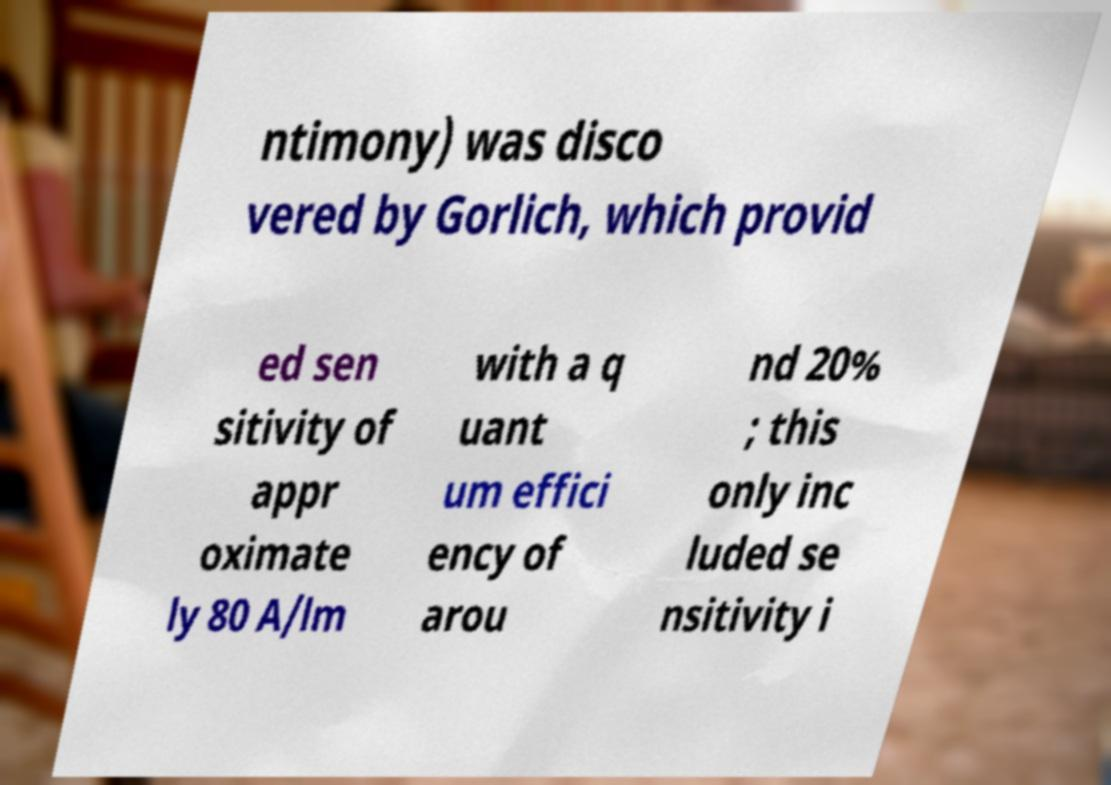Please read and relay the text visible in this image. What does it say? ntimony) was disco vered by Gorlich, which provid ed sen sitivity of appr oximate ly 80 A/lm with a q uant um effici ency of arou nd 20% ; this only inc luded se nsitivity i 